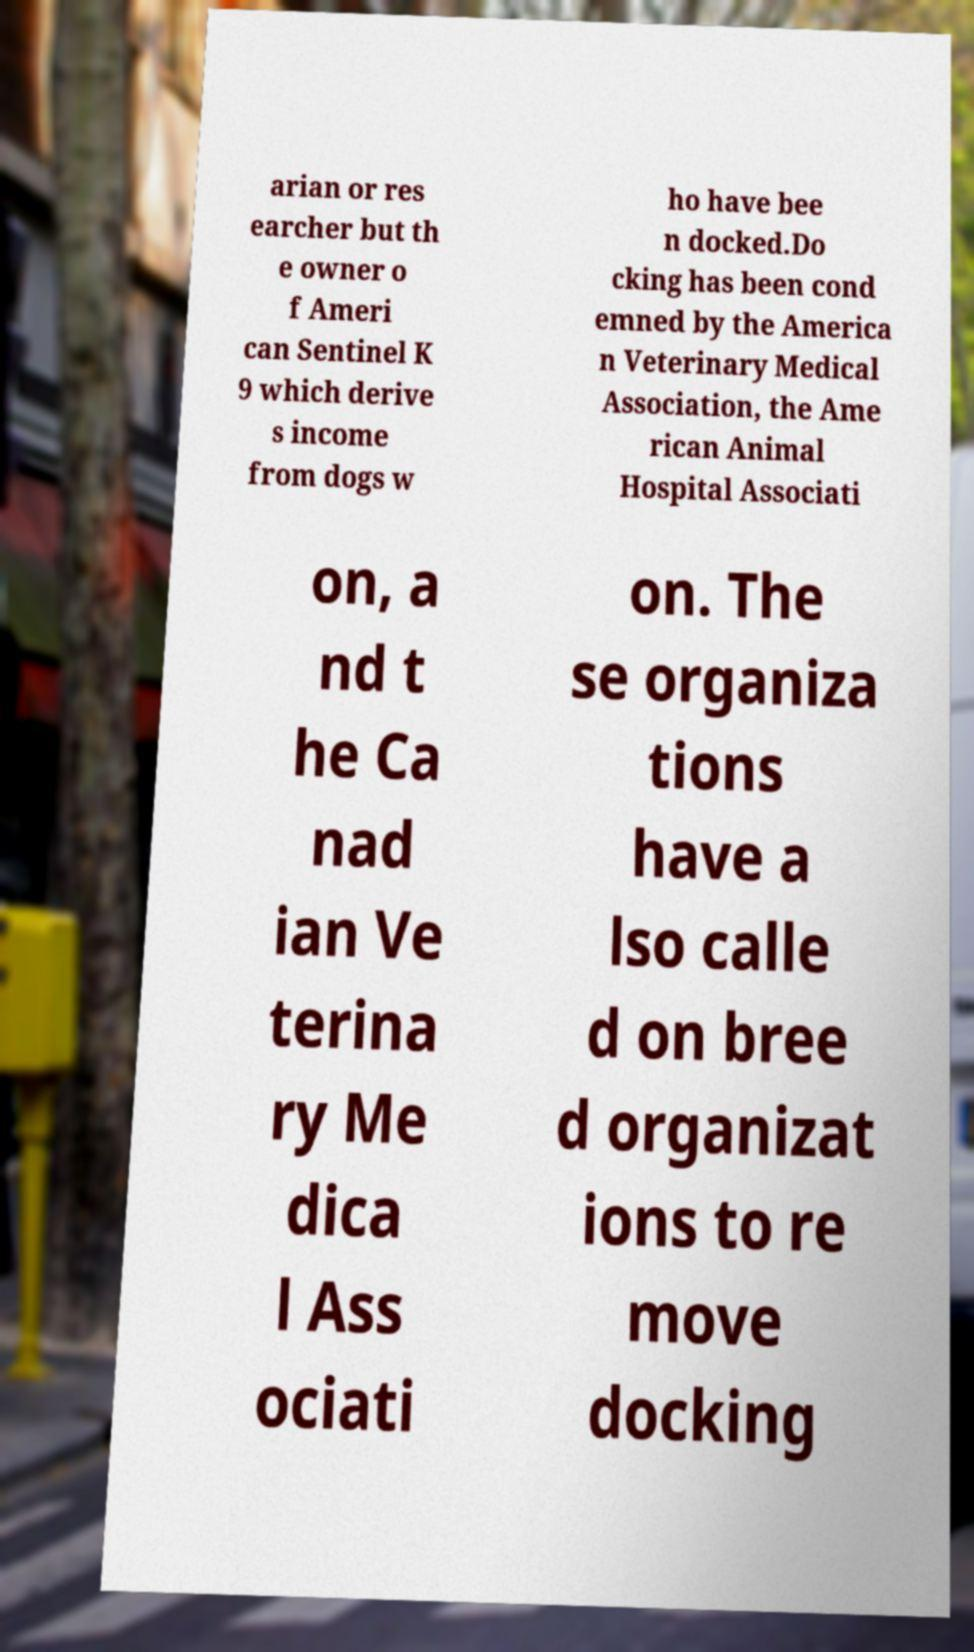Can you read and provide the text displayed in the image?This photo seems to have some interesting text. Can you extract and type it out for me? arian or res earcher but th e owner o f Ameri can Sentinel K 9 which derive s income from dogs w ho have bee n docked.Do cking has been cond emned by the America n Veterinary Medical Association, the Ame rican Animal Hospital Associati on, a nd t he Ca nad ian Ve terina ry Me dica l Ass ociati on. The se organiza tions have a lso calle d on bree d organizat ions to re move docking 